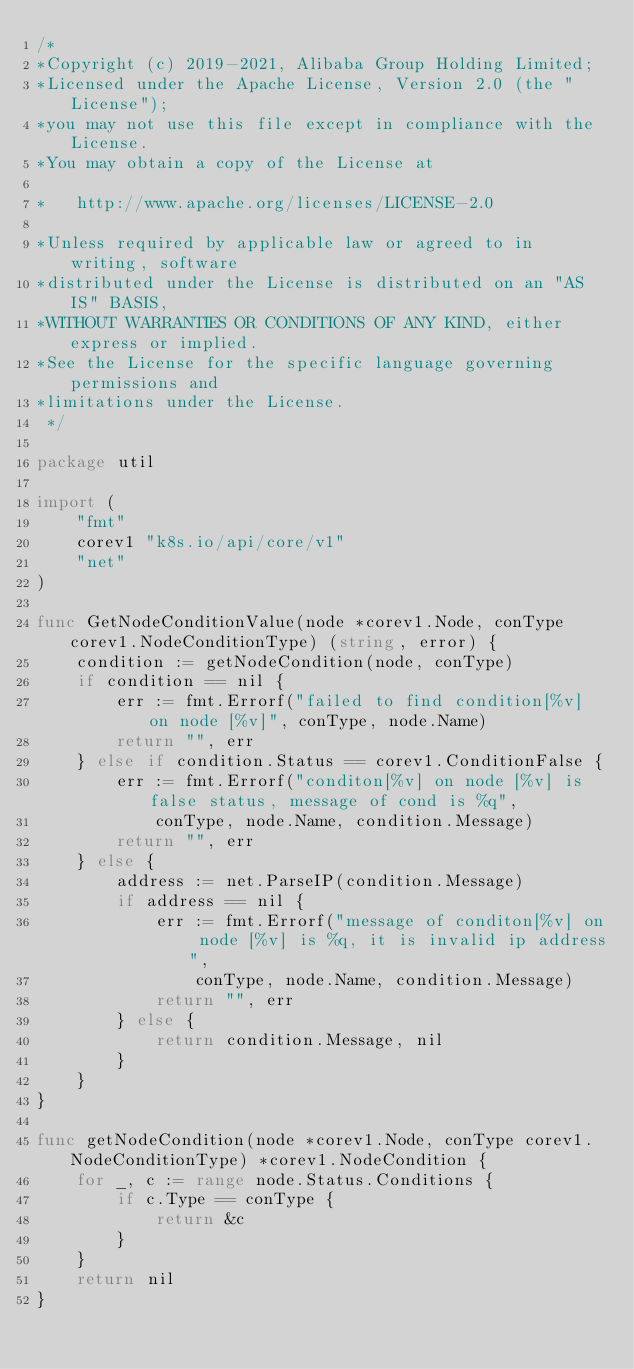Convert code to text. <code><loc_0><loc_0><loc_500><loc_500><_Go_>/*
*Copyright (c) 2019-2021, Alibaba Group Holding Limited;
*Licensed under the Apache License, Version 2.0 (the "License");
*you may not use this file except in compliance with the License.
*You may obtain a copy of the License at

*   http://www.apache.org/licenses/LICENSE-2.0

*Unless required by applicable law or agreed to in writing, software
*distributed under the License is distributed on an "AS IS" BASIS,
*WITHOUT WARRANTIES OR CONDITIONS OF ANY KIND, either express or implied.
*See the License for the specific language governing permissions and
*limitations under the License.
 */

package util

import (
	"fmt"
	corev1 "k8s.io/api/core/v1"
	"net"
)

func GetNodeConditionValue(node *corev1.Node, conType corev1.NodeConditionType) (string, error) {
	condition := getNodeCondition(node, conType)
	if condition == nil {
		err := fmt.Errorf("failed to find condition[%v] on node [%v]", conType, node.Name)
		return "", err
	} else if condition.Status == corev1.ConditionFalse {
		err := fmt.Errorf("conditon[%v] on node [%v] is false status, message of cond is %q",
			conType, node.Name, condition.Message)
		return "", err
	} else {
		address := net.ParseIP(condition.Message)
		if address == nil {
			err := fmt.Errorf("message of conditon[%v] on node [%v] is %q, it is invalid ip address",
				conType, node.Name, condition.Message)
			return "", err
		} else {
			return condition.Message, nil
		}
	}
}

func getNodeCondition(node *corev1.Node, conType corev1.NodeConditionType) *corev1.NodeCondition {
	for _, c := range node.Status.Conditions {
		if c.Type == conType {
			return &c
		}
	}
	return nil
}
</code> 